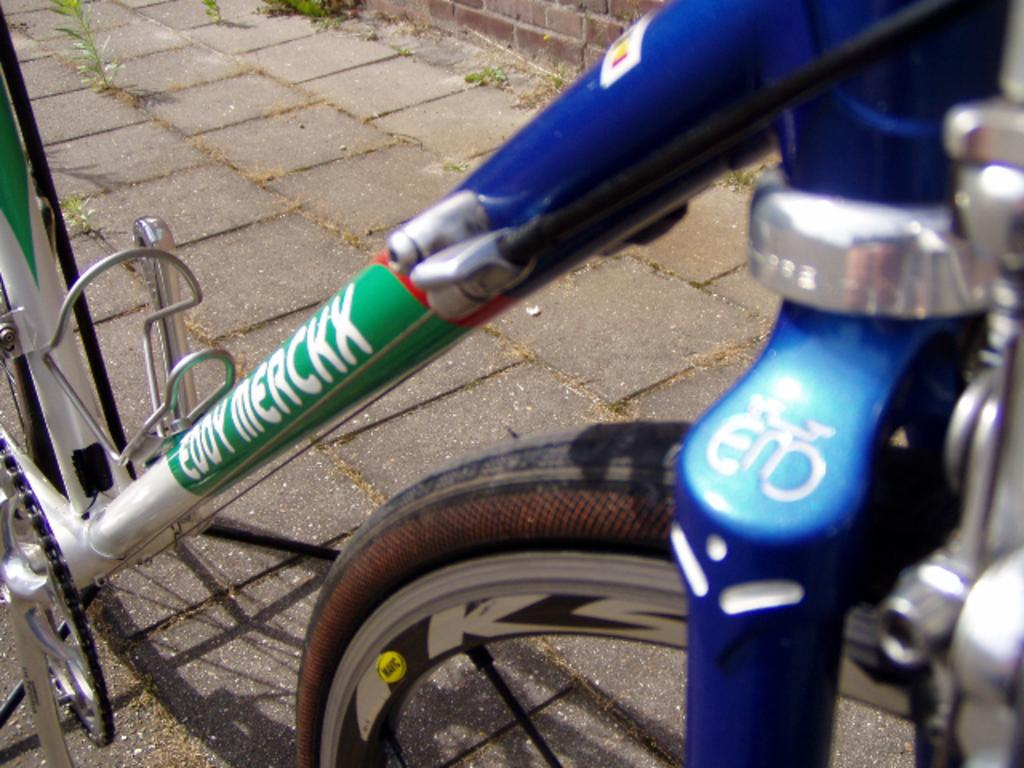What is the main object in the picture? There is a bicycle in the picture. What is written or printed on the bicycle? There is text on the bicycle. What can be seen in the background of the picture? There is a wall in the background of the picture. What type of vegetation is at the bottom of the picture? There are plants at the bottom of the picture. What type of surface is the bicycle on? There is a pavement in the picture. What type of office furniture is visible in the image? There is no office furniture present in the image; it features a bicycle with text, a wall in the background, plants at the bottom, and a pavement. 